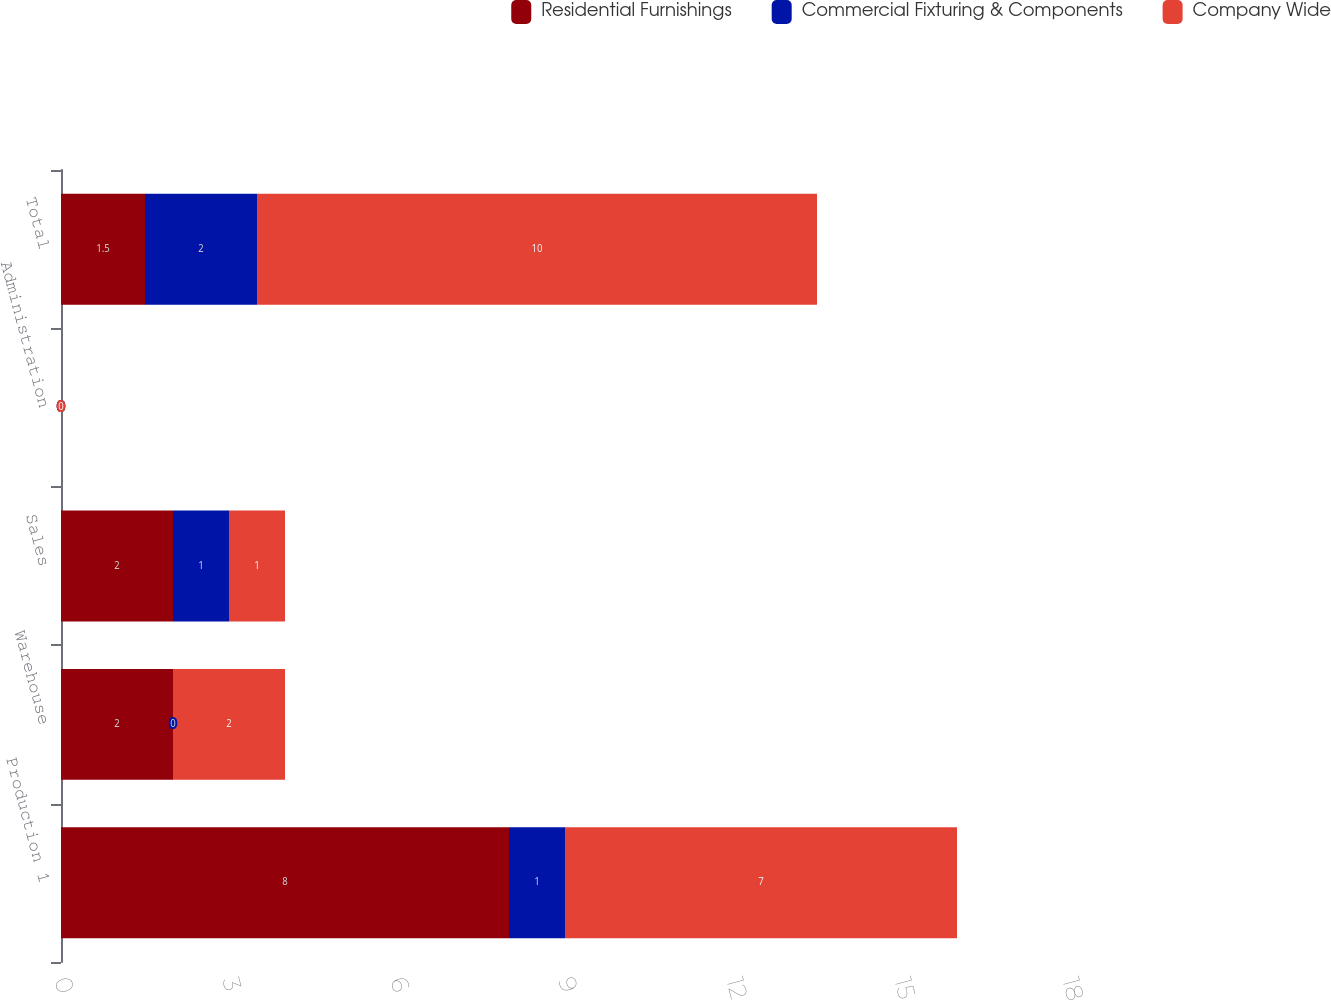Convert chart to OTSL. <chart><loc_0><loc_0><loc_500><loc_500><stacked_bar_chart><ecel><fcel>Production 1<fcel>Warehouse<fcel>Sales<fcel>Administration<fcel>Total<nl><fcel>Residential Furnishings<fcel>8<fcel>2<fcel>2<fcel>0<fcel>1.5<nl><fcel>Commercial Fixturing & Components<fcel>1<fcel>0<fcel>1<fcel>0<fcel>2<nl><fcel>Company Wide<fcel>7<fcel>2<fcel>1<fcel>0<fcel>10<nl></chart> 